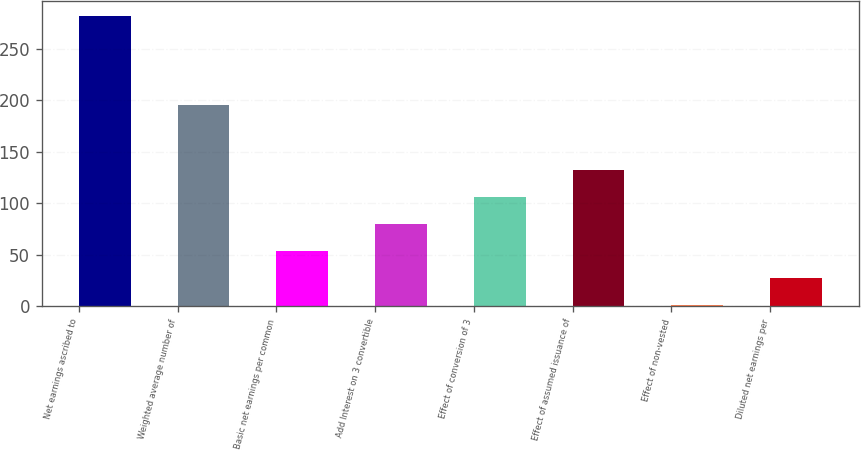Convert chart to OTSL. <chart><loc_0><loc_0><loc_500><loc_500><bar_chart><fcel>Net earnings ascribed to<fcel>Weighted average number of<fcel>Basic net earnings per common<fcel>Add Interest on 3 convertible<fcel>Effect of conversion of 3<fcel>Effect of assumed issuance of<fcel>Effect of non-vested<fcel>Diluted net earnings per<nl><fcel>282.07<fcel>195.1<fcel>53.44<fcel>79.71<fcel>105.98<fcel>132.25<fcel>0.9<fcel>27.17<nl></chart> 